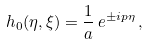Convert formula to latex. <formula><loc_0><loc_0><loc_500><loc_500>h _ { 0 } ( \eta , \xi ) = \frac { 1 } { a } \, e ^ { \pm i p \eta } \, ,</formula> 